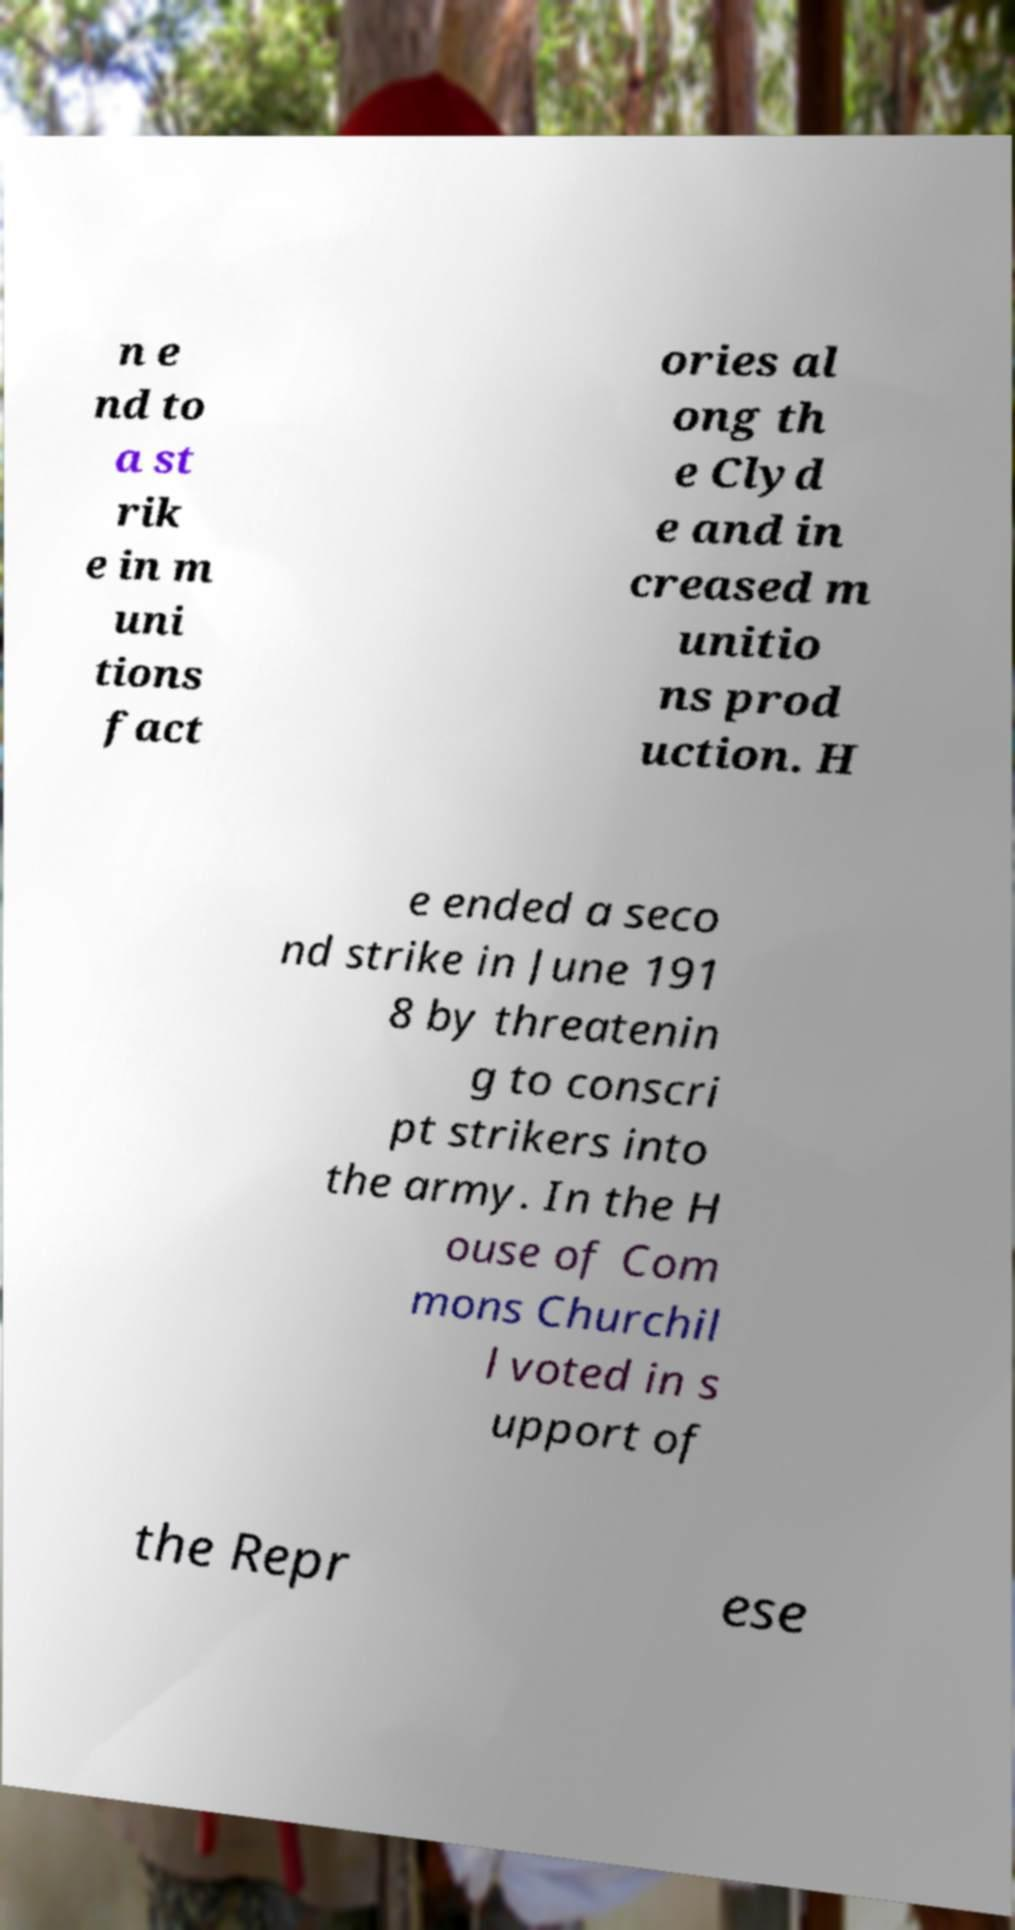For documentation purposes, I need the text within this image transcribed. Could you provide that? n e nd to a st rik e in m uni tions fact ories al ong th e Clyd e and in creased m unitio ns prod uction. H e ended a seco nd strike in June 191 8 by threatenin g to conscri pt strikers into the army. In the H ouse of Com mons Churchil l voted in s upport of the Repr ese 